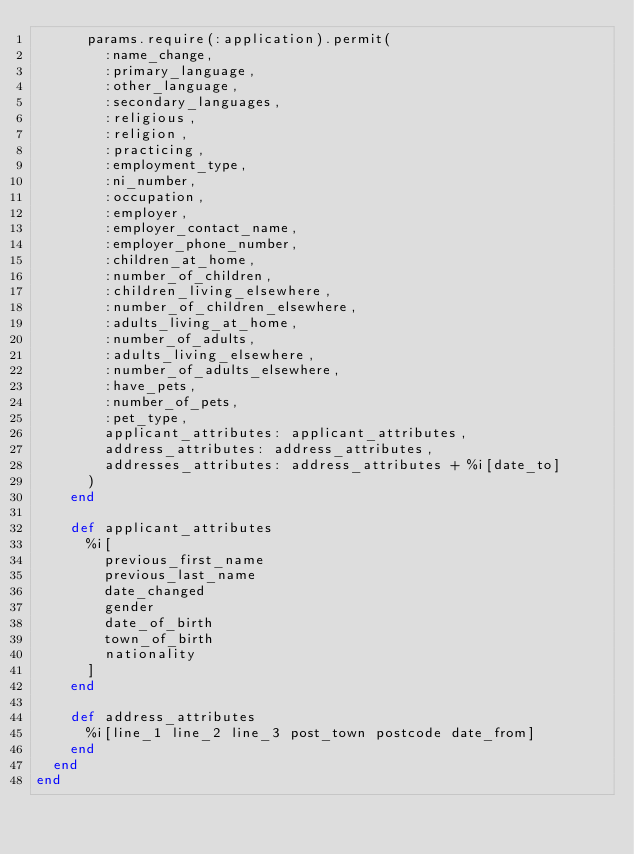Convert code to text. <code><loc_0><loc_0><loc_500><loc_500><_Ruby_>      params.require(:application).permit(
        :name_change,
        :primary_language,
        :other_language,
        :secondary_languages,
        :religious,
        :religion,
        :practicing,
        :employment_type,
        :ni_number,
        :occupation,
        :employer,
        :employer_contact_name,
        :employer_phone_number,
        :children_at_home,
        :number_of_children,
        :children_living_elsewhere,
        :number_of_children_elsewhere,
        :adults_living_at_home,
        :number_of_adults,
        :adults_living_elsewhere,
        :number_of_adults_elsewhere,
        :have_pets,
        :number_of_pets,
        :pet_type,
        applicant_attributes: applicant_attributes,
        address_attributes: address_attributes,
        addresses_attributes: address_attributes + %i[date_to]
      )
    end

    def applicant_attributes
      %i[
        previous_first_name
        previous_last_name
        date_changed
        gender
        date_of_birth
        town_of_birth
        nationality
      ]
    end

    def address_attributes
      %i[line_1 line_2 line_3 post_town postcode date_from]
    end
  end
end
</code> 